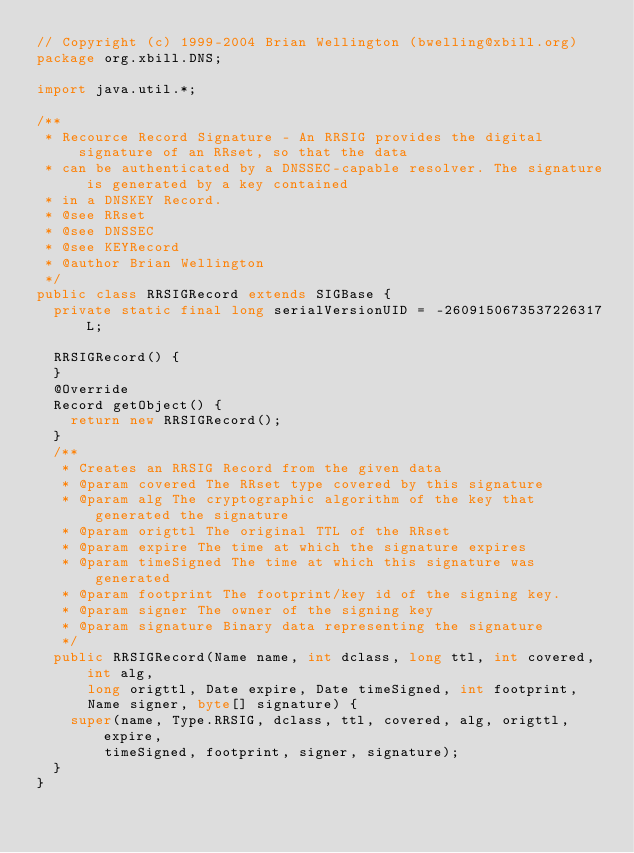<code> <loc_0><loc_0><loc_500><loc_500><_Java_>// Copyright (c) 1999-2004 Brian Wellington (bwelling@xbill.org)
package org.xbill.DNS;

import java.util.*;

/**
 * Recource Record Signature - An RRSIG provides the digital signature of an RRset, so that the data
 * can be authenticated by a DNSSEC-capable resolver. The signature is generated by a key contained
 * in a DNSKEY Record.
 * @see RRset
 * @see DNSSEC
 * @see KEYRecord
 * @author Brian Wellington
 */
public class RRSIGRecord extends SIGBase {
	private static final long serialVersionUID = -2609150673537226317L;

	RRSIGRecord() {
	}
	@Override
	Record getObject() {
		return new RRSIGRecord();
	}
	/**
	 * Creates an RRSIG Record from the given data
	 * @param covered The RRset type covered by this signature
	 * @param alg The cryptographic algorithm of the key that generated the signature
	 * @param origttl The original TTL of the RRset
	 * @param expire The time at which the signature expires
	 * @param timeSigned The time at which this signature was generated
	 * @param footprint The footprint/key id of the signing key.
	 * @param signer The owner of the signing key
	 * @param signature Binary data representing the signature
	 */
	public RRSIGRecord(Name name, int dclass, long ttl, int covered, int alg,
			long origttl, Date expire, Date timeSigned, int footprint,
			Name signer, byte[] signature) {
		super(name, Type.RRSIG, dclass, ttl, covered, alg, origttl, expire,
				timeSigned, footprint, signer, signature);
	}
}
</code> 